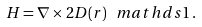Convert formula to latex. <formula><loc_0><loc_0><loc_500><loc_500>H = \nabla \times 2 D ( r ) \, \ m a t h d s { 1 } \, .</formula> 